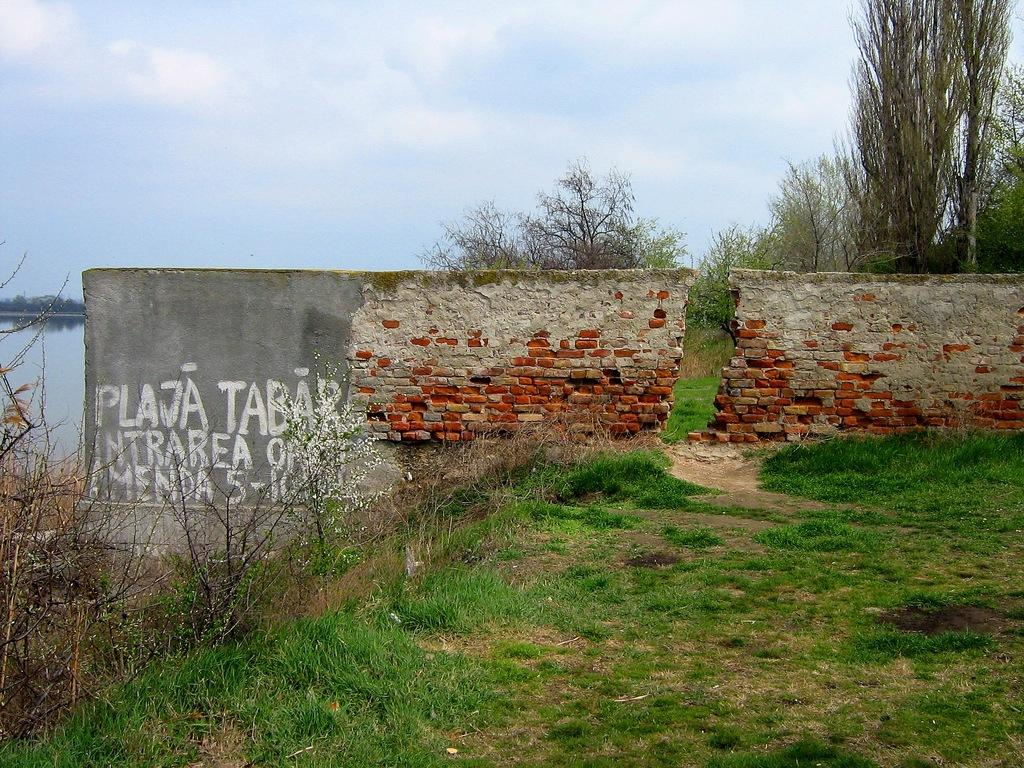What is the condition of the wall in the image? The wall in the image is broken with text on it. What type of vegetation can be seen in the image? There are trees and plants visible in the image. What is the water feature in the image? The water is visible in the image. What type of ground cover is present in the image? There is grass in the image. What can be seen in the background of the image? The sky with clouds is visible in the background of the image. What type of magic is being performed in the image? There is no magic or any indication of a magical event in the image. What historical event is depicted in the image? The image does not depict any specific historical event. 